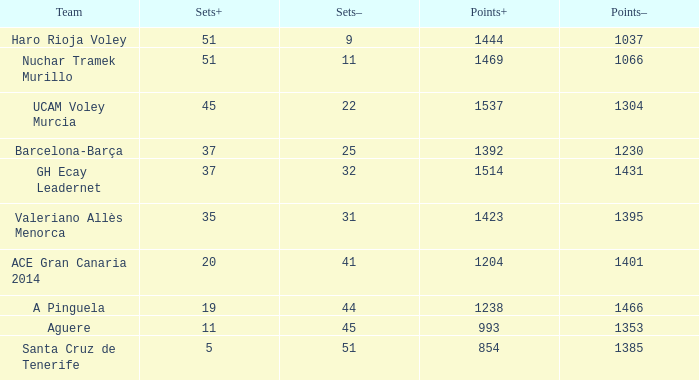What is the maximum points+ value when the points- value exceeds 1385, a sets+ value is less than 37, and a sets- value is greater than 41? 1238.0. 